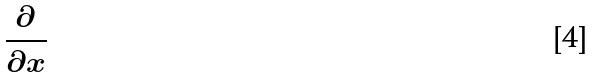Convert formula to latex. <formula><loc_0><loc_0><loc_500><loc_500>\frac { \partial } { \partial x }</formula> 